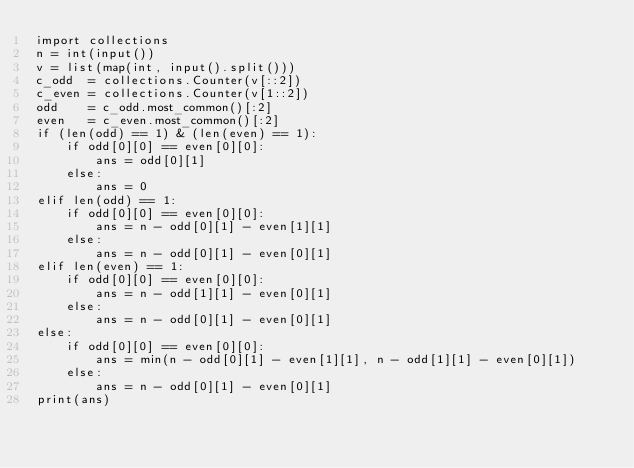Convert code to text. <code><loc_0><loc_0><loc_500><loc_500><_Python_>import collections
n = int(input())
v = list(map(int, input().split()))
c_odd  = collections.Counter(v[::2])
c_even = collections.Counter(v[1::2])
odd    = c_odd.most_common()[:2]
even   = c_even.most_common()[:2]
if (len(odd) == 1) & (len(even) == 1):
	if odd[0][0] == even[0][0]:
		ans = odd[0][1]
	else:
		ans = 0
elif len(odd) == 1:
	if odd[0][0] == even[0][0]:
		ans = n - odd[0][1] - even[1][1]
	else:
		ans = n - odd[0][1] - even[0][1]
elif len(even) == 1:
	if odd[0][0] == even[0][0]:
		ans = n - odd[1][1] - even[0][1]
	else:
		ans = n - odd[0][1] - even[0][1]
else:
	if odd[0][0] == even[0][0]:
		ans = min(n - odd[0][1] - even[1][1], n - odd[1][1] - even[0][1])
	else:
		ans = n - odd[0][1] - even[0][1]
print(ans)</code> 